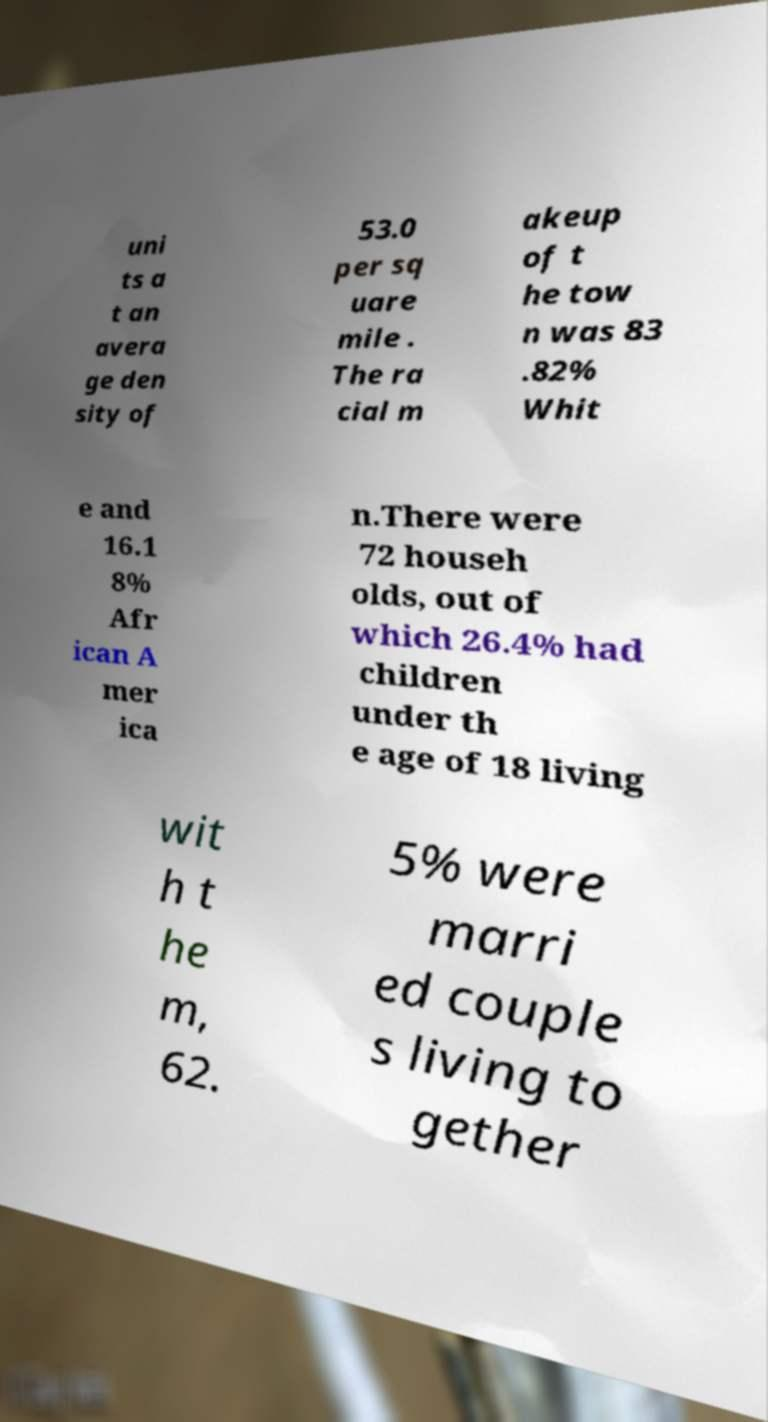Please read and relay the text visible in this image. What does it say? uni ts a t an avera ge den sity of 53.0 per sq uare mile . The ra cial m akeup of t he tow n was 83 .82% Whit e and 16.1 8% Afr ican A mer ica n.There were 72 househ olds, out of which 26.4% had children under th e age of 18 living wit h t he m, 62. 5% were marri ed couple s living to gether 